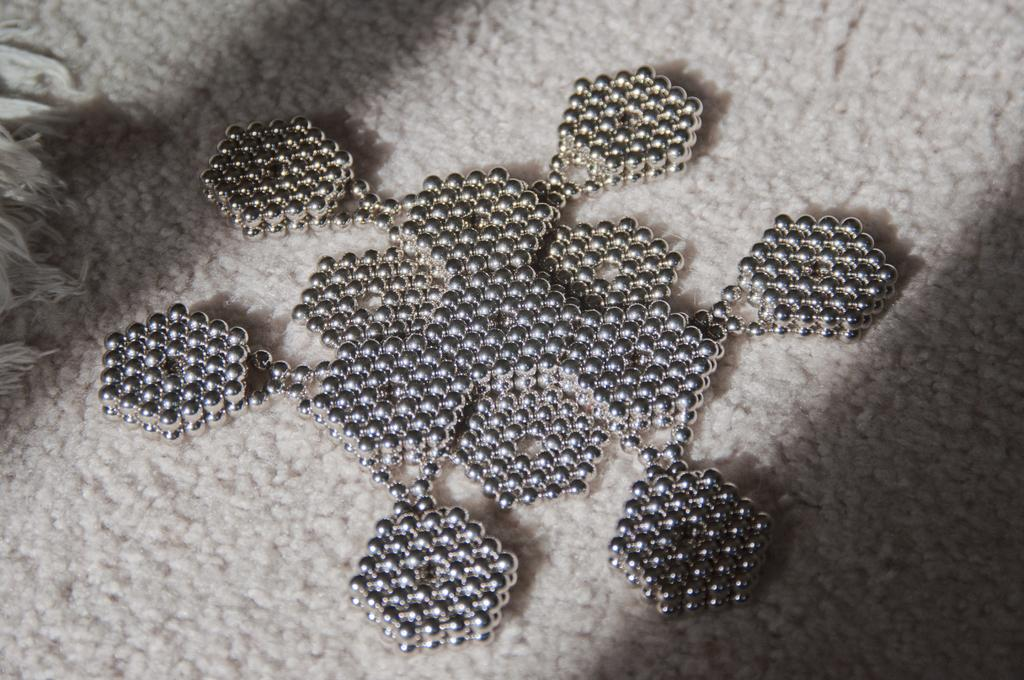What is the main subject of the image? The main subject of the image is decor on a mat. Where is the decor located in the image? The decor is located in the center of the mat. What type of tooth is used to cover the decor in the image? There is no tooth present in the image, and the decor is not being covered by any object. 